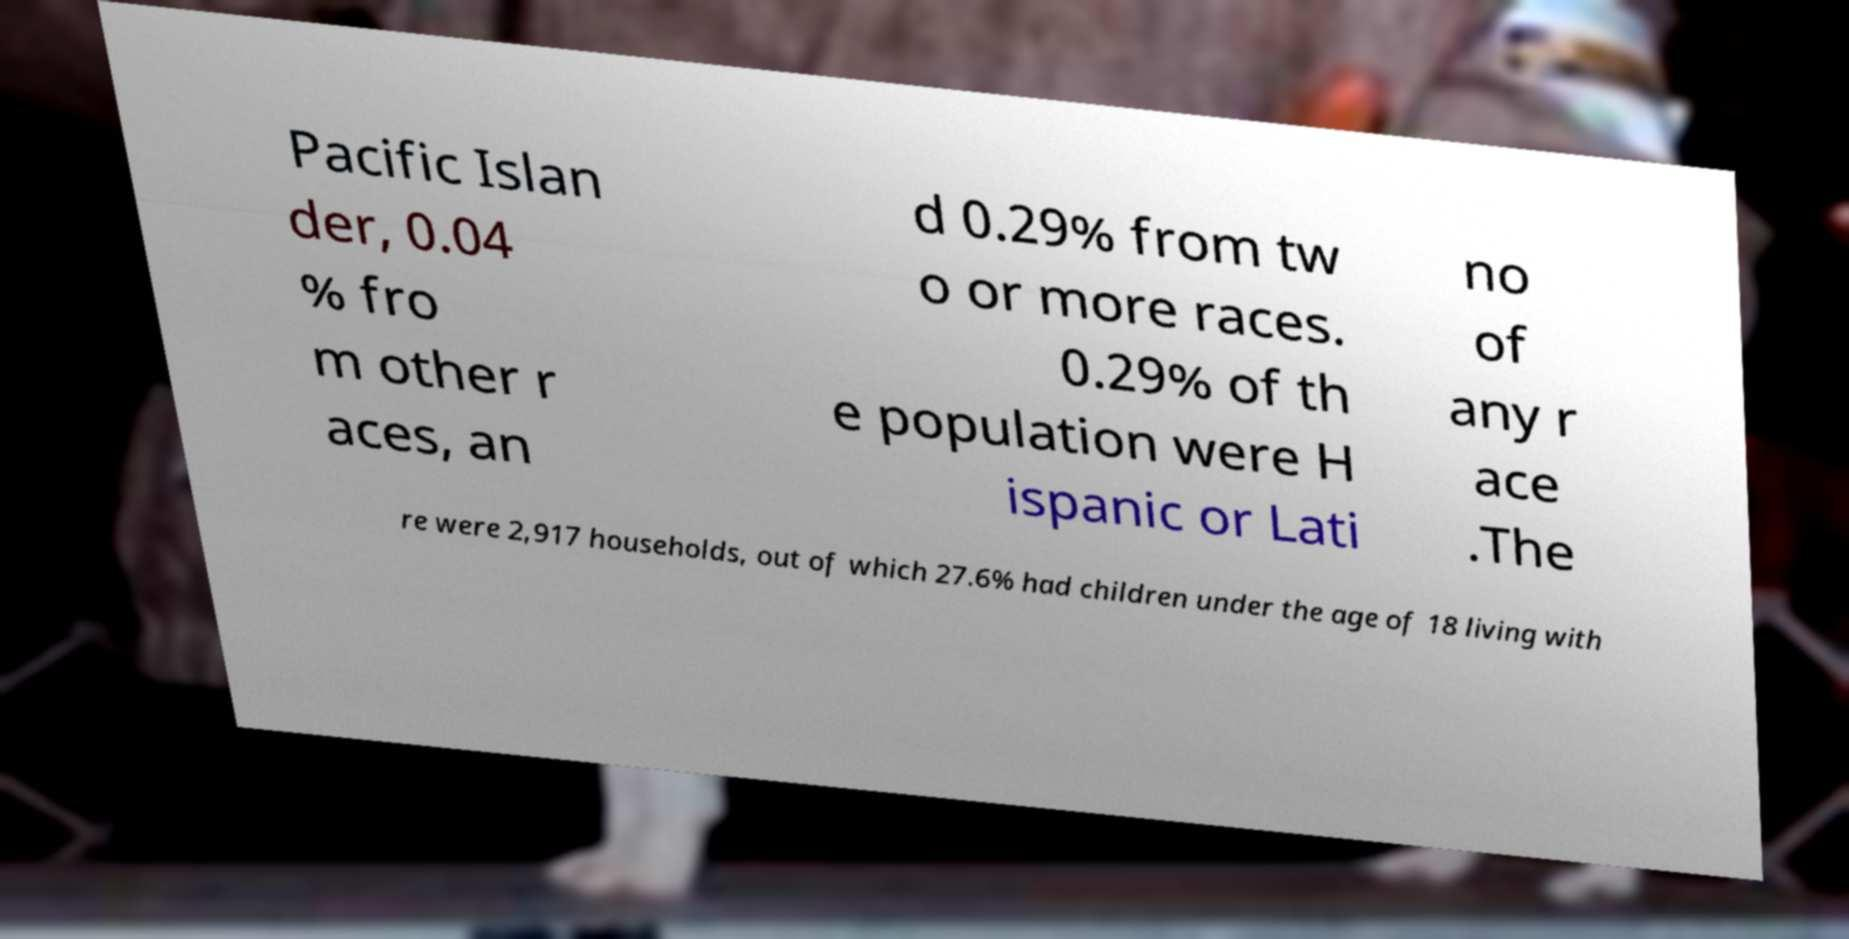Please identify and transcribe the text found in this image. Pacific Islan der, 0.04 % fro m other r aces, an d 0.29% from tw o or more races. 0.29% of th e population were H ispanic or Lati no of any r ace .The re were 2,917 households, out of which 27.6% had children under the age of 18 living with 